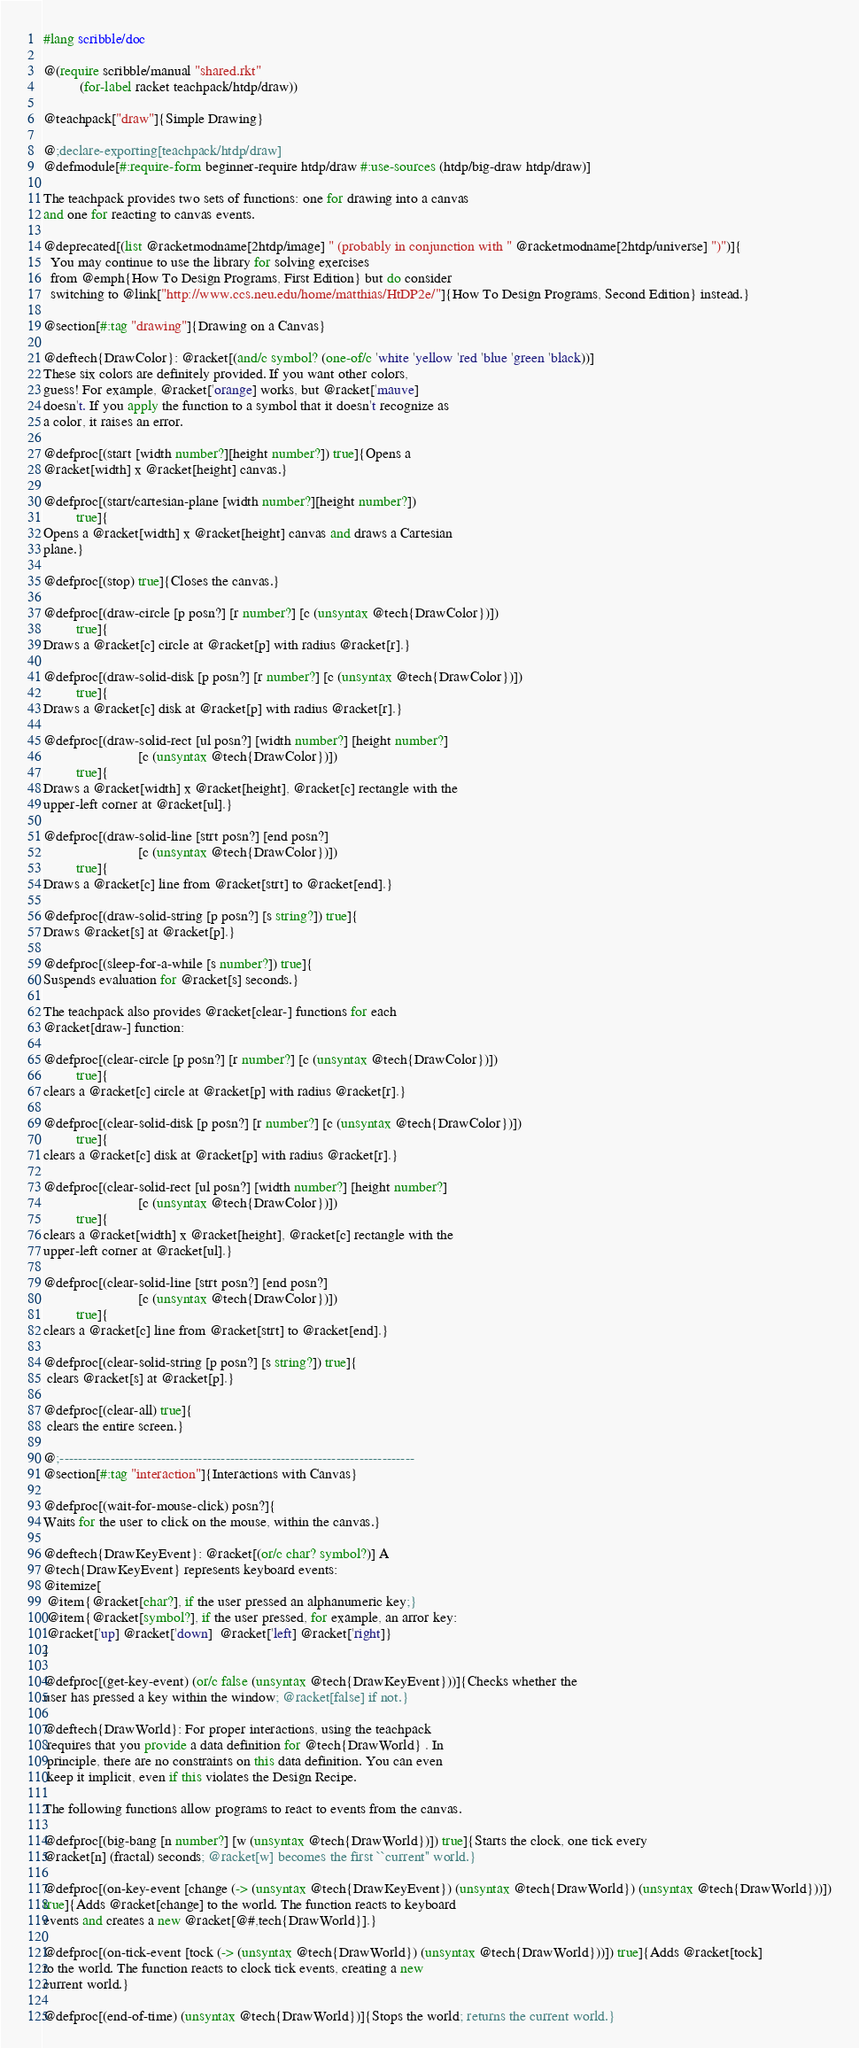Convert code to text. <code><loc_0><loc_0><loc_500><loc_500><_Racket_>#lang scribble/doc

@(require scribble/manual "shared.rkt"
          (for-label racket teachpack/htdp/draw))

@teachpack["draw"]{Simple Drawing}

@;declare-exporting[teachpack/htdp/draw]
@defmodule[#:require-form beginner-require htdp/draw #:use-sources (htdp/big-draw htdp/draw)]

The teachpack provides two sets of functions: one for drawing into a canvas
and one for reacting to canvas events. 

@deprecated[(list @racketmodname[2htdp/image] " (probably in conjunction with " @racketmodname[2htdp/universe] ")")]{
  You may continue to use the library for solving exercises 
  from @emph{How To Design Programs, First Edition} but do consider
  switching to @link["http://www.ccs.neu.edu/home/matthias/HtDP2e/"]{How To Design Programs, Second Edition} instead.}

@section[#:tag "drawing"]{Drawing on a Canvas}

@deftech{DrawColor}: @racket[(and/c symbol? (one-of/c 'white 'yellow 'red 'blue 'green 'black))]
These six colors are definitely provided. If you want other colors,
guess! For example, @racket['orange] works, but @racket['mauve]
doesn't. If you apply the function to a symbol that it doesn't recognize as
a color, it raises an error.

@defproc[(start [width number?][height number?]) true]{Opens a
@racket[width] x @racket[height] canvas.} 

@defproc[(start/cartesian-plane [width number?][height number?])
         true]{
Opens a @racket[width] x @racket[height] canvas and draws a Cartesian
plane.}

@defproc[(stop) true]{Closes the canvas.}

@defproc[(draw-circle [p posn?] [r number?] [c (unsyntax @tech{DrawColor})])
         true]{
Draws a @racket[c] circle at @racket[p] with radius @racket[r].}

@defproc[(draw-solid-disk [p posn?] [r number?] [c (unsyntax @tech{DrawColor})])
         true]{
Draws a @racket[c] disk at @racket[p] with radius @racket[r].}

@defproc[(draw-solid-rect [ul posn?] [width number?] [height number?]
                          [c (unsyntax @tech{DrawColor})])
         true]{
Draws a @racket[width] x @racket[height], @racket[c] rectangle with the
upper-left corner at @racket[ul].}

@defproc[(draw-solid-line [strt posn?] [end posn?]
                          [c (unsyntax @tech{DrawColor})])
         true]{
Draws a @racket[c] line from @racket[strt] to @racket[end].}

@defproc[(draw-solid-string [p posn?] [s string?]) true]{
Draws @racket[s] at @racket[p].}

@defproc[(sleep-for-a-while [s number?]) true]{
Suspends evaluation for @racket[s] seconds.}

The teachpack also provides @racket[clear-] functions for each
@racket[draw-] function:

@defproc[(clear-circle [p posn?] [r number?] [c (unsyntax @tech{DrawColor})])
         true]{
clears a @racket[c] circle at @racket[p] with radius @racket[r].}

@defproc[(clear-solid-disk [p posn?] [r number?] [c (unsyntax @tech{DrawColor})])
         true]{
clears a @racket[c] disk at @racket[p] with radius @racket[r].}

@defproc[(clear-solid-rect [ul posn?] [width number?] [height number?]
                          [c (unsyntax @tech{DrawColor})])
         true]{
clears a @racket[width] x @racket[height], @racket[c] rectangle with the
upper-left corner at @racket[ul].}

@defproc[(clear-solid-line [strt posn?] [end posn?]
                          [c (unsyntax @tech{DrawColor})])
         true]{
clears a @racket[c] line from @racket[strt] to @racket[end].}

@defproc[(clear-solid-string [p posn?] [s string?]) true]{
 clears @racket[s] at @racket[p].}

@defproc[(clear-all) true]{
 clears the entire screen.}

@;-----------------------------------------------------------------------------
@section[#:tag "interaction"]{Interactions with Canvas}

@defproc[(wait-for-mouse-click) posn?]{
Waits for the user to click on the mouse, within the canvas.}

@deftech{DrawKeyEvent}: @racket[(or/c char? symbol?)] A
@tech{DrawKeyEvent} represents keyboard events: 
@itemize[
 @item{@racket[char?], if the user pressed an alphanumeric key;}
 @item{@racket[symbol?], if the user pressed, for example, an arror key:
 @racket['up] @racket['down]  @racket['left] @racket['right]}
]

@defproc[(get-key-event) (or/c false (unsyntax @tech{DrawKeyEvent}))]{Checks whether the
user has pressed a key within the window; @racket[false] if not.}

@deftech{DrawWorld}: For proper interactions, using the teachpack
 requires that you provide a data definition for @tech{DrawWorld} . In
 principle, there are no constraints on this data definition. You can even
 keep it implicit, even if this violates the Design Recipe.

The following functions allow programs to react to events from the canvas.

@defproc[(big-bang [n number?] [w (unsyntax @tech{DrawWorld})]) true]{Starts the clock, one tick every
@racket[n] (fractal) seconds; @racket[w] becomes the first ``current'' world.}

@defproc[(on-key-event [change (-> (unsyntax @tech{DrawKeyEvent}) (unsyntax @tech{DrawWorld}) (unsyntax @tech{DrawWorld}))])
true]{Adds @racket[change] to the world. The function reacts to keyboard
events and creates a new @racket[@#,tech{DrawWorld}].}

@defproc[(on-tick-event [tock (-> (unsyntax @tech{DrawWorld}) (unsyntax @tech{DrawWorld}))]) true]{Adds @racket[tock]
to the world. The function reacts to clock tick events, creating a new
current world.}

@defproc[(end-of-time) (unsyntax @tech{DrawWorld})]{Stops the world; returns the current world.} 
</code> 